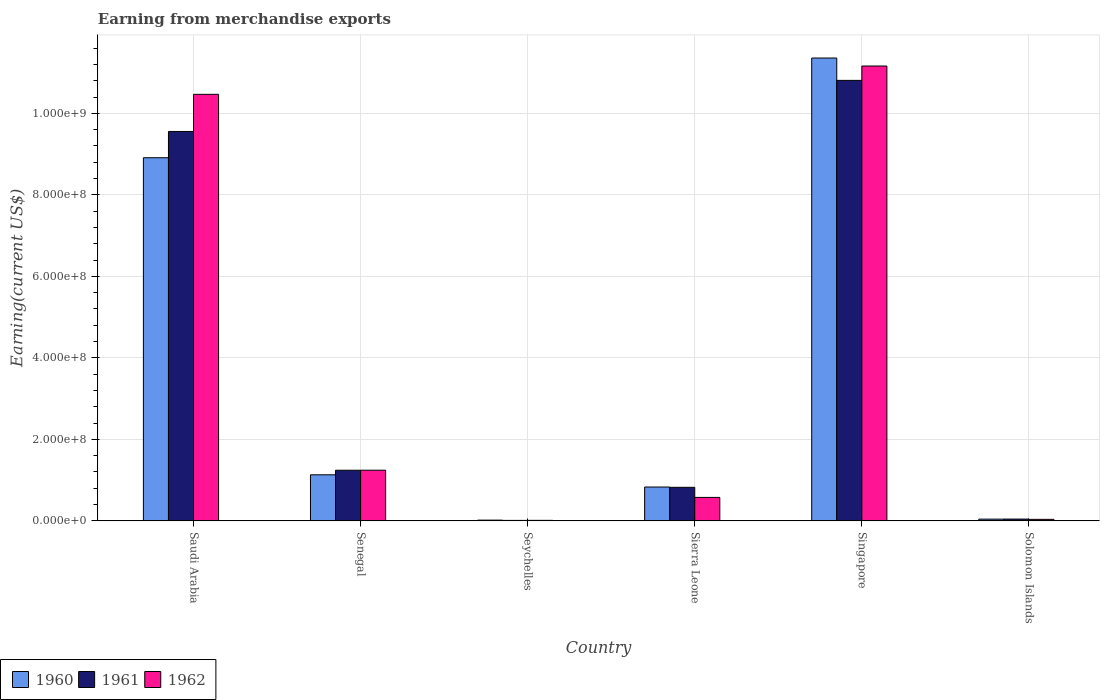How many groups of bars are there?
Make the answer very short. 6. How many bars are there on the 4th tick from the left?
Your answer should be compact. 3. What is the label of the 5th group of bars from the left?
Your answer should be compact. Singapore. In how many cases, is the number of bars for a given country not equal to the number of legend labels?
Your answer should be very brief. 0. What is the amount earned from merchandise exports in 1962 in Saudi Arabia?
Your answer should be very brief. 1.05e+09. Across all countries, what is the maximum amount earned from merchandise exports in 1960?
Offer a very short reply. 1.14e+09. Across all countries, what is the minimum amount earned from merchandise exports in 1960?
Ensure brevity in your answer.  1.70e+06. In which country was the amount earned from merchandise exports in 1961 maximum?
Your answer should be compact. Singapore. In which country was the amount earned from merchandise exports in 1962 minimum?
Ensure brevity in your answer.  Seychelles. What is the total amount earned from merchandise exports in 1960 in the graph?
Provide a short and direct response. 2.23e+09. What is the difference between the amount earned from merchandise exports in 1960 in Senegal and that in Seychelles?
Offer a terse response. 1.11e+08. What is the difference between the amount earned from merchandise exports in 1961 in Senegal and the amount earned from merchandise exports in 1960 in Singapore?
Provide a short and direct response. -1.01e+09. What is the average amount earned from merchandise exports in 1960 per country?
Your answer should be compact. 3.71e+08. What is the difference between the amount earned from merchandise exports of/in 1962 and amount earned from merchandise exports of/in 1960 in Solomon Islands?
Give a very brief answer. -5.17e+05. In how many countries, is the amount earned from merchandise exports in 1962 greater than 240000000 US$?
Keep it short and to the point. 2. What is the ratio of the amount earned from merchandise exports in 1962 in Singapore to that in Solomon Islands?
Make the answer very short. 306.37. Is the amount earned from merchandise exports in 1962 in Saudi Arabia less than that in Sierra Leone?
Ensure brevity in your answer.  No. Is the difference between the amount earned from merchandise exports in 1962 in Senegal and Solomon Islands greater than the difference between the amount earned from merchandise exports in 1960 in Senegal and Solomon Islands?
Make the answer very short. Yes. What is the difference between the highest and the second highest amount earned from merchandise exports in 1962?
Provide a succinct answer. 9.92e+08. What is the difference between the highest and the lowest amount earned from merchandise exports in 1961?
Make the answer very short. 1.08e+09. Is the sum of the amount earned from merchandise exports in 1960 in Sierra Leone and Solomon Islands greater than the maximum amount earned from merchandise exports in 1962 across all countries?
Your response must be concise. No. What does the 3rd bar from the left in Senegal represents?
Your answer should be very brief. 1962. What does the 2nd bar from the right in Solomon Islands represents?
Offer a very short reply. 1961. Are all the bars in the graph horizontal?
Offer a very short reply. No. What is the difference between two consecutive major ticks on the Y-axis?
Keep it short and to the point. 2.00e+08. Are the values on the major ticks of Y-axis written in scientific E-notation?
Provide a succinct answer. Yes. Where does the legend appear in the graph?
Your response must be concise. Bottom left. How many legend labels are there?
Keep it short and to the point. 3. What is the title of the graph?
Offer a terse response. Earning from merchandise exports. What is the label or title of the X-axis?
Your response must be concise. Country. What is the label or title of the Y-axis?
Give a very brief answer. Earning(current US$). What is the Earning(current US$) of 1960 in Saudi Arabia?
Ensure brevity in your answer.  8.91e+08. What is the Earning(current US$) of 1961 in Saudi Arabia?
Make the answer very short. 9.56e+08. What is the Earning(current US$) of 1962 in Saudi Arabia?
Offer a very short reply. 1.05e+09. What is the Earning(current US$) of 1960 in Senegal?
Keep it short and to the point. 1.13e+08. What is the Earning(current US$) of 1961 in Senegal?
Your answer should be very brief. 1.24e+08. What is the Earning(current US$) of 1962 in Senegal?
Your answer should be very brief. 1.24e+08. What is the Earning(current US$) of 1960 in Seychelles?
Offer a terse response. 1.70e+06. What is the Earning(current US$) of 1961 in Seychelles?
Provide a succinct answer. 1.06e+06. What is the Earning(current US$) in 1962 in Seychelles?
Give a very brief answer. 1.17e+06. What is the Earning(current US$) of 1960 in Sierra Leone?
Offer a very short reply. 8.30e+07. What is the Earning(current US$) in 1961 in Sierra Leone?
Offer a very short reply. 8.22e+07. What is the Earning(current US$) in 1962 in Sierra Leone?
Provide a short and direct response. 5.75e+07. What is the Earning(current US$) in 1960 in Singapore?
Your answer should be very brief. 1.14e+09. What is the Earning(current US$) of 1961 in Singapore?
Ensure brevity in your answer.  1.08e+09. What is the Earning(current US$) in 1962 in Singapore?
Your answer should be compact. 1.12e+09. What is the Earning(current US$) in 1960 in Solomon Islands?
Make the answer very short. 4.16e+06. What is the Earning(current US$) of 1961 in Solomon Islands?
Make the answer very short. 4.29e+06. What is the Earning(current US$) of 1962 in Solomon Islands?
Offer a very short reply. 3.64e+06. Across all countries, what is the maximum Earning(current US$) in 1960?
Offer a very short reply. 1.14e+09. Across all countries, what is the maximum Earning(current US$) of 1961?
Your answer should be compact. 1.08e+09. Across all countries, what is the maximum Earning(current US$) of 1962?
Give a very brief answer. 1.12e+09. Across all countries, what is the minimum Earning(current US$) in 1960?
Offer a very short reply. 1.70e+06. Across all countries, what is the minimum Earning(current US$) in 1961?
Offer a terse response. 1.06e+06. Across all countries, what is the minimum Earning(current US$) in 1962?
Give a very brief answer. 1.17e+06. What is the total Earning(current US$) in 1960 in the graph?
Keep it short and to the point. 2.23e+09. What is the total Earning(current US$) of 1961 in the graph?
Keep it short and to the point. 2.25e+09. What is the total Earning(current US$) of 1962 in the graph?
Offer a very short reply. 2.35e+09. What is the difference between the Earning(current US$) in 1960 in Saudi Arabia and that in Senegal?
Offer a very short reply. 7.78e+08. What is the difference between the Earning(current US$) in 1961 in Saudi Arabia and that in Senegal?
Offer a terse response. 8.31e+08. What is the difference between the Earning(current US$) of 1962 in Saudi Arabia and that in Senegal?
Your response must be concise. 9.22e+08. What is the difference between the Earning(current US$) of 1960 in Saudi Arabia and that in Seychelles?
Your response must be concise. 8.89e+08. What is the difference between the Earning(current US$) in 1961 in Saudi Arabia and that in Seychelles?
Provide a succinct answer. 9.54e+08. What is the difference between the Earning(current US$) in 1962 in Saudi Arabia and that in Seychelles?
Your response must be concise. 1.05e+09. What is the difference between the Earning(current US$) in 1960 in Saudi Arabia and that in Sierra Leone?
Give a very brief answer. 8.08e+08. What is the difference between the Earning(current US$) in 1961 in Saudi Arabia and that in Sierra Leone?
Offer a very short reply. 8.73e+08. What is the difference between the Earning(current US$) of 1962 in Saudi Arabia and that in Sierra Leone?
Keep it short and to the point. 9.89e+08. What is the difference between the Earning(current US$) in 1960 in Saudi Arabia and that in Singapore?
Your answer should be very brief. -2.45e+08. What is the difference between the Earning(current US$) in 1961 in Saudi Arabia and that in Singapore?
Your answer should be very brief. -1.25e+08. What is the difference between the Earning(current US$) in 1962 in Saudi Arabia and that in Singapore?
Your answer should be very brief. -6.96e+07. What is the difference between the Earning(current US$) of 1960 in Saudi Arabia and that in Solomon Islands?
Offer a very short reply. 8.87e+08. What is the difference between the Earning(current US$) in 1961 in Saudi Arabia and that in Solomon Islands?
Ensure brevity in your answer.  9.51e+08. What is the difference between the Earning(current US$) of 1962 in Saudi Arabia and that in Solomon Islands?
Your response must be concise. 1.04e+09. What is the difference between the Earning(current US$) in 1960 in Senegal and that in Seychelles?
Offer a terse response. 1.11e+08. What is the difference between the Earning(current US$) of 1961 in Senegal and that in Seychelles?
Offer a very short reply. 1.23e+08. What is the difference between the Earning(current US$) of 1962 in Senegal and that in Seychelles?
Give a very brief answer. 1.23e+08. What is the difference between the Earning(current US$) of 1960 in Senegal and that in Sierra Leone?
Offer a terse response. 3.00e+07. What is the difference between the Earning(current US$) in 1961 in Senegal and that in Sierra Leone?
Provide a succinct answer. 4.19e+07. What is the difference between the Earning(current US$) of 1962 in Senegal and that in Sierra Leone?
Your response must be concise. 6.68e+07. What is the difference between the Earning(current US$) of 1960 in Senegal and that in Singapore?
Offer a terse response. -1.02e+09. What is the difference between the Earning(current US$) of 1961 in Senegal and that in Singapore?
Provide a succinct answer. -9.57e+08. What is the difference between the Earning(current US$) in 1962 in Senegal and that in Singapore?
Your answer should be very brief. -9.92e+08. What is the difference between the Earning(current US$) of 1960 in Senegal and that in Solomon Islands?
Your answer should be compact. 1.09e+08. What is the difference between the Earning(current US$) in 1961 in Senegal and that in Solomon Islands?
Ensure brevity in your answer.  1.20e+08. What is the difference between the Earning(current US$) in 1962 in Senegal and that in Solomon Islands?
Make the answer very short. 1.21e+08. What is the difference between the Earning(current US$) of 1960 in Seychelles and that in Sierra Leone?
Your response must be concise. -8.13e+07. What is the difference between the Earning(current US$) in 1961 in Seychelles and that in Sierra Leone?
Provide a succinct answer. -8.12e+07. What is the difference between the Earning(current US$) in 1962 in Seychelles and that in Sierra Leone?
Your response must be concise. -5.63e+07. What is the difference between the Earning(current US$) in 1960 in Seychelles and that in Singapore?
Give a very brief answer. -1.13e+09. What is the difference between the Earning(current US$) in 1961 in Seychelles and that in Singapore?
Your answer should be compact. -1.08e+09. What is the difference between the Earning(current US$) of 1962 in Seychelles and that in Singapore?
Your answer should be compact. -1.12e+09. What is the difference between the Earning(current US$) of 1960 in Seychelles and that in Solomon Islands?
Provide a short and direct response. -2.46e+06. What is the difference between the Earning(current US$) in 1961 in Seychelles and that in Solomon Islands?
Offer a very short reply. -3.23e+06. What is the difference between the Earning(current US$) of 1962 in Seychelles and that in Solomon Islands?
Your answer should be compact. -2.48e+06. What is the difference between the Earning(current US$) of 1960 in Sierra Leone and that in Singapore?
Provide a succinct answer. -1.05e+09. What is the difference between the Earning(current US$) of 1961 in Sierra Leone and that in Singapore?
Give a very brief answer. -9.99e+08. What is the difference between the Earning(current US$) of 1962 in Sierra Leone and that in Singapore?
Ensure brevity in your answer.  -1.06e+09. What is the difference between the Earning(current US$) of 1960 in Sierra Leone and that in Solomon Islands?
Offer a terse response. 7.88e+07. What is the difference between the Earning(current US$) in 1961 in Sierra Leone and that in Solomon Islands?
Your answer should be very brief. 7.80e+07. What is the difference between the Earning(current US$) of 1962 in Sierra Leone and that in Solomon Islands?
Provide a short and direct response. 5.38e+07. What is the difference between the Earning(current US$) in 1960 in Singapore and that in Solomon Islands?
Keep it short and to the point. 1.13e+09. What is the difference between the Earning(current US$) in 1961 in Singapore and that in Solomon Islands?
Your answer should be very brief. 1.08e+09. What is the difference between the Earning(current US$) in 1962 in Singapore and that in Solomon Islands?
Provide a succinct answer. 1.11e+09. What is the difference between the Earning(current US$) of 1960 in Saudi Arabia and the Earning(current US$) of 1961 in Senegal?
Offer a very short reply. 7.67e+08. What is the difference between the Earning(current US$) of 1960 in Saudi Arabia and the Earning(current US$) of 1962 in Senegal?
Your response must be concise. 7.67e+08. What is the difference between the Earning(current US$) of 1961 in Saudi Arabia and the Earning(current US$) of 1962 in Senegal?
Make the answer very short. 8.31e+08. What is the difference between the Earning(current US$) in 1960 in Saudi Arabia and the Earning(current US$) in 1961 in Seychelles?
Your response must be concise. 8.90e+08. What is the difference between the Earning(current US$) in 1960 in Saudi Arabia and the Earning(current US$) in 1962 in Seychelles?
Give a very brief answer. 8.90e+08. What is the difference between the Earning(current US$) in 1961 in Saudi Arabia and the Earning(current US$) in 1962 in Seychelles?
Provide a short and direct response. 9.54e+08. What is the difference between the Earning(current US$) of 1960 in Saudi Arabia and the Earning(current US$) of 1961 in Sierra Leone?
Your answer should be compact. 8.09e+08. What is the difference between the Earning(current US$) of 1960 in Saudi Arabia and the Earning(current US$) of 1962 in Sierra Leone?
Offer a terse response. 8.34e+08. What is the difference between the Earning(current US$) in 1961 in Saudi Arabia and the Earning(current US$) in 1962 in Sierra Leone?
Provide a short and direct response. 8.98e+08. What is the difference between the Earning(current US$) in 1960 in Saudi Arabia and the Earning(current US$) in 1961 in Singapore?
Keep it short and to the point. -1.90e+08. What is the difference between the Earning(current US$) in 1960 in Saudi Arabia and the Earning(current US$) in 1962 in Singapore?
Your answer should be very brief. -2.25e+08. What is the difference between the Earning(current US$) of 1961 in Saudi Arabia and the Earning(current US$) of 1962 in Singapore?
Your answer should be compact. -1.61e+08. What is the difference between the Earning(current US$) of 1960 in Saudi Arabia and the Earning(current US$) of 1961 in Solomon Islands?
Make the answer very short. 8.87e+08. What is the difference between the Earning(current US$) of 1960 in Saudi Arabia and the Earning(current US$) of 1962 in Solomon Islands?
Your response must be concise. 8.87e+08. What is the difference between the Earning(current US$) in 1961 in Saudi Arabia and the Earning(current US$) in 1962 in Solomon Islands?
Provide a succinct answer. 9.52e+08. What is the difference between the Earning(current US$) in 1960 in Senegal and the Earning(current US$) in 1961 in Seychelles?
Provide a succinct answer. 1.12e+08. What is the difference between the Earning(current US$) in 1960 in Senegal and the Earning(current US$) in 1962 in Seychelles?
Your answer should be compact. 1.12e+08. What is the difference between the Earning(current US$) of 1961 in Senegal and the Earning(current US$) of 1962 in Seychelles?
Provide a short and direct response. 1.23e+08. What is the difference between the Earning(current US$) of 1960 in Senegal and the Earning(current US$) of 1961 in Sierra Leone?
Keep it short and to the point. 3.07e+07. What is the difference between the Earning(current US$) in 1960 in Senegal and the Earning(current US$) in 1962 in Sierra Leone?
Offer a terse response. 5.55e+07. What is the difference between the Earning(current US$) of 1961 in Senegal and the Earning(current US$) of 1962 in Sierra Leone?
Give a very brief answer. 6.67e+07. What is the difference between the Earning(current US$) of 1960 in Senegal and the Earning(current US$) of 1961 in Singapore?
Make the answer very short. -9.68e+08. What is the difference between the Earning(current US$) of 1960 in Senegal and the Earning(current US$) of 1962 in Singapore?
Provide a succinct answer. -1.00e+09. What is the difference between the Earning(current US$) in 1961 in Senegal and the Earning(current US$) in 1962 in Singapore?
Give a very brief answer. -9.92e+08. What is the difference between the Earning(current US$) in 1960 in Senegal and the Earning(current US$) in 1961 in Solomon Islands?
Your answer should be very brief. 1.09e+08. What is the difference between the Earning(current US$) in 1960 in Senegal and the Earning(current US$) in 1962 in Solomon Islands?
Your response must be concise. 1.09e+08. What is the difference between the Earning(current US$) of 1961 in Senegal and the Earning(current US$) of 1962 in Solomon Islands?
Provide a short and direct response. 1.21e+08. What is the difference between the Earning(current US$) of 1960 in Seychelles and the Earning(current US$) of 1961 in Sierra Leone?
Provide a succinct answer. -8.05e+07. What is the difference between the Earning(current US$) in 1960 in Seychelles and the Earning(current US$) in 1962 in Sierra Leone?
Ensure brevity in your answer.  -5.58e+07. What is the difference between the Earning(current US$) in 1961 in Seychelles and the Earning(current US$) in 1962 in Sierra Leone?
Your answer should be very brief. -5.64e+07. What is the difference between the Earning(current US$) of 1960 in Seychelles and the Earning(current US$) of 1961 in Singapore?
Offer a very short reply. -1.08e+09. What is the difference between the Earning(current US$) of 1960 in Seychelles and the Earning(current US$) of 1962 in Singapore?
Make the answer very short. -1.11e+09. What is the difference between the Earning(current US$) of 1961 in Seychelles and the Earning(current US$) of 1962 in Singapore?
Provide a short and direct response. -1.12e+09. What is the difference between the Earning(current US$) in 1960 in Seychelles and the Earning(current US$) in 1961 in Solomon Islands?
Keep it short and to the point. -2.59e+06. What is the difference between the Earning(current US$) in 1960 in Seychelles and the Earning(current US$) in 1962 in Solomon Islands?
Provide a succinct answer. -1.94e+06. What is the difference between the Earning(current US$) in 1961 in Seychelles and the Earning(current US$) in 1962 in Solomon Islands?
Provide a short and direct response. -2.58e+06. What is the difference between the Earning(current US$) of 1960 in Sierra Leone and the Earning(current US$) of 1961 in Singapore?
Ensure brevity in your answer.  -9.98e+08. What is the difference between the Earning(current US$) of 1960 in Sierra Leone and the Earning(current US$) of 1962 in Singapore?
Your response must be concise. -1.03e+09. What is the difference between the Earning(current US$) in 1961 in Sierra Leone and the Earning(current US$) in 1962 in Singapore?
Make the answer very short. -1.03e+09. What is the difference between the Earning(current US$) in 1960 in Sierra Leone and the Earning(current US$) in 1961 in Solomon Islands?
Give a very brief answer. 7.87e+07. What is the difference between the Earning(current US$) of 1960 in Sierra Leone and the Earning(current US$) of 1962 in Solomon Islands?
Keep it short and to the point. 7.93e+07. What is the difference between the Earning(current US$) of 1961 in Sierra Leone and the Earning(current US$) of 1962 in Solomon Islands?
Give a very brief answer. 7.86e+07. What is the difference between the Earning(current US$) of 1960 in Singapore and the Earning(current US$) of 1961 in Solomon Islands?
Offer a very short reply. 1.13e+09. What is the difference between the Earning(current US$) of 1960 in Singapore and the Earning(current US$) of 1962 in Solomon Islands?
Your answer should be very brief. 1.13e+09. What is the difference between the Earning(current US$) in 1961 in Singapore and the Earning(current US$) in 1962 in Solomon Islands?
Your answer should be very brief. 1.08e+09. What is the average Earning(current US$) in 1960 per country?
Your answer should be compact. 3.71e+08. What is the average Earning(current US$) of 1961 per country?
Your response must be concise. 3.75e+08. What is the average Earning(current US$) of 1962 per country?
Your answer should be compact. 3.92e+08. What is the difference between the Earning(current US$) of 1960 and Earning(current US$) of 1961 in Saudi Arabia?
Provide a succinct answer. -6.44e+07. What is the difference between the Earning(current US$) of 1960 and Earning(current US$) of 1962 in Saudi Arabia?
Keep it short and to the point. -1.56e+08. What is the difference between the Earning(current US$) of 1961 and Earning(current US$) of 1962 in Saudi Arabia?
Your answer should be very brief. -9.11e+07. What is the difference between the Earning(current US$) in 1960 and Earning(current US$) in 1961 in Senegal?
Make the answer very short. -1.12e+07. What is the difference between the Earning(current US$) of 1960 and Earning(current US$) of 1962 in Senegal?
Provide a succinct answer. -1.13e+07. What is the difference between the Earning(current US$) of 1961 and Earning(current US$) of 1962 in Senegal?
Your response must be concise. -8.10e+04. What is the difference between the Earning(current US$) of 1960 and Earning(current US$) of 1961 in Seychelles?
Your response must be concise. 6.42e+05. What is the difference between the Earning(current US$) in 1960 and Earning(current US$) in 1962 in Seychelles?
Keep it short and to the point. 5.32e+05. What is the difference between the Earning(current US$) of 1961 and Earning(current US$) of 1962 in Seychelles?
Your answer should be very brief. -1.09e+05. What is the difference between the Earning(current US$) in 1960 and Earning(current US$) in 1961 in Sierra Leone?
Provide a succinct answer. 7.27e+05. What is the difference between the Earning(current US$) in 1960 and Earning(current US$) in 1962 in Sierra Leone?
Make the answer very short. 2.55e+07. What is the difference between the Earning(current US$) in 1961 and Earning(current US$) in 1962 in Sierra Leone?
Keep it short and to the point. 2.48e+07. What is the difference between the Earning(current US$) in 1960 and Earning(current US$) in 1961 in Singapore?
Offer a terse response. 5.49e+07. What is the difference between the Earning(current US$) of 1960 and Earning(current US$) of 1962 in Singapore?
Your answer should be compact. 1.96e+07. What is the difference between the Earning(current US$) of 1961 and Earning(current US$) of 1962 in Singapore?
Offer a terse response. -3.53e+07. What is the difference between the Earning(current US$) of 1960 and Earning(current US$) of 1961 in Solomon Islands?
Provide a succinct answer. -1.24e+05. What is the difference between the Earning(current US$) of 1960 and Earning(current US$) of 1962 in Solomon Islands?
Make the answer very short. 5.17e+05. What is the difference between the Earning(current US$) of 1961 and Earning(current US$) of 1962 in Solomon Islands?
Keep it short and to the point. 6.42e+05. What is the ratio of the Earning(current US$) in 1960 in Saudi Arabia to that in Senegal?
Provide a short and direct response. 7.89. What is the ratio of the Earning(current US$) in 1961 in Saudi Arabia to that in Senegal?
Ensure brevity in your answer.  7.7. What is the ratio of the Earning(current US$) in 1962 in Saudi Arabia to that in Senegal?
Offer a very short reply. 8.42. What is the ratio of the Earning(current US$) of 1960 in Saudi Arabia to that in Seychelles?
Provide a short and direct response. 524.18. What is the ratio of the Earning(current US$) of 1961 in Saudi Arabia to that in Seychelles?
Offer a terse response. 902.83. What is the ratio of the Earning(current US$) of 1962 in Saudi Arabia to that in Seychelles?
Provide a short and direct response. 896.43. What is the ratio of the Earning(current US$) in 1960 in Saudi Arabia to that in Sierra Leone?
Provide a short and direct response. 10.74. What is the ratio of the Earning(current US$) in 1961 in Saudi Arabia to that in Sierra Leone?
Provide a succinct answer. 11.62. What is the ratio of the Earning(current US$) in 1962 in Saudi Arabia to that in Sierra Leone?
Keep it short and to the point. 18.21. What is the ratio of the Earning(current US$) of 1960 in Saudi Arabia to that in Singapore?
Your response must be concise. 0.78. What is the ratio of the Earning(current US$) in 1961 in Saudi Arabia to that in Singapore?
Give a very brief answer. 0.88. What is the ratio of the Earning(current US$) of 1962 in Saudi Arabia to that in Singapore?
Keep it short and to the point. 0.94. What is the ratio of the Earning(current US$) of 1960 in Saudi Arabia to that in Solomon Islands?
Offer a very short reply. 214.17. What is the ratio of the Earning(current US$) of 1961 in Saudi Arabia to that in Solomon Islands?
Make the answer very short. 222.99. What is the ratio of the Earning(current US$) in 1962 in Saudi Arabia to that in Solomon Islands?
Ensure brevity in your answer.  287.28. What is the ratio of the Earning(current US$) of 1960 in Senegal to that in Seychelles?
Offer a very short reply. 66.44. What is the ratio of the Earning(current US$) of 1961 in Senegal to that in Seychelles?
Give a very brief answer. 117.31. What is the ratio of the Earning(current US$) in 1962 in Senegal to that in Seychelles?
Offer a very short reply. 106.41. What is the ratio of the Earning(current US$) in 1960 in Senegal to that in Sierra Leone?
Your answer should be very brief. 1.36. What is the ratio of the Earning(current US$) of 1961 in Senegal to that in Sierra Leone?
Offer a very short reply. 1.51. What is the ratio of the Earning(current US$) of 1962 in Senegal to that in Sierra Leone?
Give a very brief answer. 2.16. What is the ratio of the Earning(current US$) in 1960 in Senegal to that in Singapore?
Your answer should be very brief. 0.1. What is the ratio of the Earning(current US$) of 1961 in Senegal to that in Singapore?
Your answer should be compact. 0.11. What is the ratio of the Earning(current US$) of 1962 in Senegal to that in Singapore?
Ensure brevity in your answer.  0.11. What is the ratio of the Earning(current US$) of 1960 in Senegal to that in Solomon Islands?
Provide a succinct answer. 27.14. What is the ratio of the Earning(current US$) of 1961 in Senegal to that in Solomon Islands?
Offer a terse response. 28.98. What is the ratio of the Earning(current US$) of 1962 in Senegal to that in Solomon Islands?
Keep it short and to the point. 34.1. What is the ratio of the Earning(current US$) of 1960 in Seychelles to that in Sierra Leone?
Provide a succinct answer. 0.02. What is the ratio of the Earning(current US$) in 1961 in Seychelles to that in Sierra Leone?
Make the answer very short. 0.01. What is the ratio of the Earning(current US$) of 1962 in Seychelles to that in Sierra Leone?
Ensure brevity in your answer.  0.02. What is the ratio of the Earning(current US$) in 1960 in Seychelles to that in Singapore?
Make the answer very short. 0. What is the ratio of the Earning(current US$) of 1962 in Seychelles to that in Singapore?
Your response must be concise. 0. What is the ratio of the Earning(current US$) in 1960 in Seychelles to that in Solomon Islands?
Provide a succinct answer. 0.41. What is the ratio of the Earning(current US$) of 1961 in Seychelles to that in Solomon Islands?
Provide a short and direct response. 0.25. What is the ratio of the Earning(current US$) of 1962 in Seychelles to that in Solomon Islands?
Offer a very short reply. 0.32. What is the ratio of the Earning(current US$) in 1960 in Sierra Leone to that in Singapore?
Your response must be concise. 0.07. What is the ratio of the Earning(current US$) of 1961 in Sierra Leone to that in Singapore?
Offer a very short reply. 0.08. What is the ratio of the Earning(current US$) in 1962 in Sierra Leone to that in Singapore?
Offer a terse response. 0.05. What is the ratio of the Earning(current US$) in 1960 in Sierra Leone to that in Solomon Islands?
Give a very brief answer. 19.94. What is the ratio of the Earning(current US$) of 1961 in Sierra Leone to that in Solomon Islands?
Keep it short and to the point. 19.19. What is the ratio of the Earning(current US$) in 1962 in Sierra Leone to that in Solomon Islands?
Provide a short and direct response. 15.78. What is the ratio of the Earning(current US$) in 1960 in Singapore to that in Solomon Islands?
Provide a succinct answer. 272.98. What is the ratio of the Earning(current US$) of 1961 in Singapore to that in Solomon Islands?
Give a very brief answer. 252.25. What is the ratio of the Earning(current US$) in 1962 in Singapore to that in Solomon Islands?
Offer a very short reply. 306.37. What is the difference between the highest and the second highest Earning(current US$) in 1960?
Your answer should be compact. 2.45e+08. What is the difference between the highest and the second highest Earning(current US$) in 1961?
Give a very brief answer. 1.25e+08. What is the difference between the highest and the second highest Earning(current US$) of 1962?
Keep it short and to the point. 6.96e+07. What is the difference between the highest and the lowest Earning(current US$) in 1960?
Ensure brevity in your answer.  1.13e+09. What is the difference between the highest and the lowest Earning(current US$) of 1961?
Keep it short and to the point. 1.08e+09. What is the difference between the highest and the lowest Earning(current US$) in 1962?
Ensure brevity in your answer.  1.12e+09. 